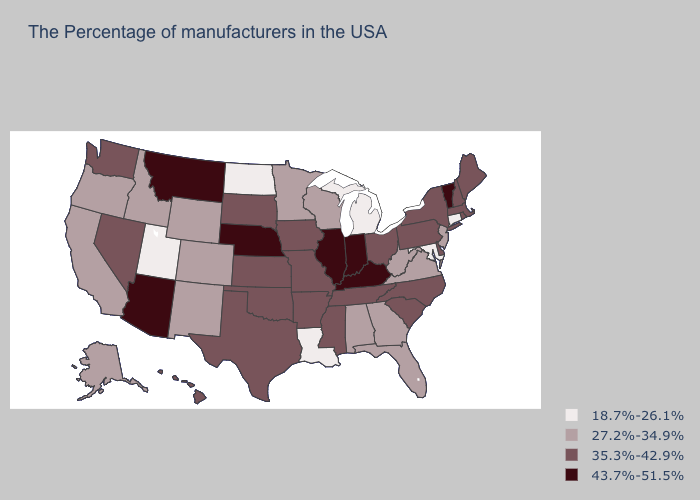What is the value of Arizona?
Concise answer only. 43.7%-51.5%. Name the states that have a value in the range 43.7%-51.5%?
Give a very brief answer. Vermont, Kentucky, Indiana, Illinois, Nebraska, Montana, Arizona. How many symbols are there in the legend?
Answer briefly. 4. Name the states that have a value in the range 35.3%-42.9%?
Concise answer only. Maine, Massachusetts, Rhode Island, New Hampshire, New York, Delaware, Pennsylvania, North Carolina, South Carolina, Ohio, Tennessee, Mississippi, Missouri, Arkansas, Iowa, Kansas, Oklahoma, Texas, South Dakota, Nevada, Washington, Hawaii. Name the states that have a value in the range 27.2%-34.9%?
Quick response, please. New Jersey, Virginia, West Virginia, Florida, Georgia, Alabama, Wisconsin, Minnesota, Wyoming, Colorado, New Mexico, Idaho, California, Oregon, Alaska. Name the states that have a value in the range 27.2%-34.9%?
Short answer required. New Jersey, Virginia, West Virginia, Florida, Georgia, Alabama, Wisconsin, Minnesota, Wyoming, Colorado, New Mexico, Idaho, California, Oregon, Alaska. Name the states that have a value in the range 18.7%-26.1%?
Be succinct. Connecticut, Maryland, Michigan, Louisiana, North Dakota, Utah. Name the states that have a value in the range 35.3%-42.9%?
Be succinct. Maine, Massachusetts, Rhode Island, New Hampshire, New York, Delaware, Pennsylvania, North Carolina, South Carolina, Ohio, Tennessee, Mississippi, Missouri, Arkansas, Iowa, Kansas, Oklahoma, Texas, South Dakota, Nevada, Washington, Hawaii. Does Iowa have the same value as Alabama?
Concise answer only. No. What is the value of Alabama?
Give a very brief answer. 27.2%-34.9%. Among the states that border Kansas , does Nebraska have the highest value?
Answer briefly. Yes. What is the value of Massachusetts?
Write a very short answer. 35.3%-42.9%. What is the value of Virginia?
Be succinct. 27.2%-34.9%. Which states have the lowest value in the USA?
Give a very brief answer. Connecticut, Maryland, Michigan, Louisiana, North Dakota, Utah. Among the states that border Arkansas , does Louisiana have the highest value?
Short answer required. No. 